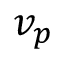<formula> <loc_0><loc_0><loc_500><loc_500>v _ { p }</formula> 